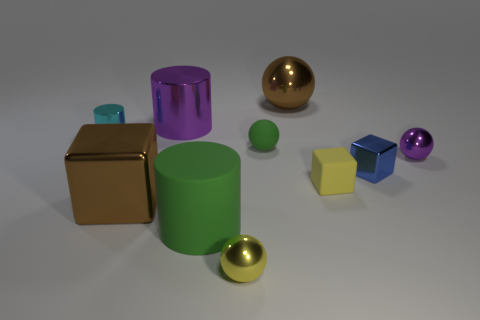What is the shape of the object that is the same color as the rubber cylinder? The object sharing the same color as the rubber cylinder is a sphere. The sphere, like the cylinder, appears to have a smooth surface reflecting light similarly, which suggests that it may be made of a similar material as well. 